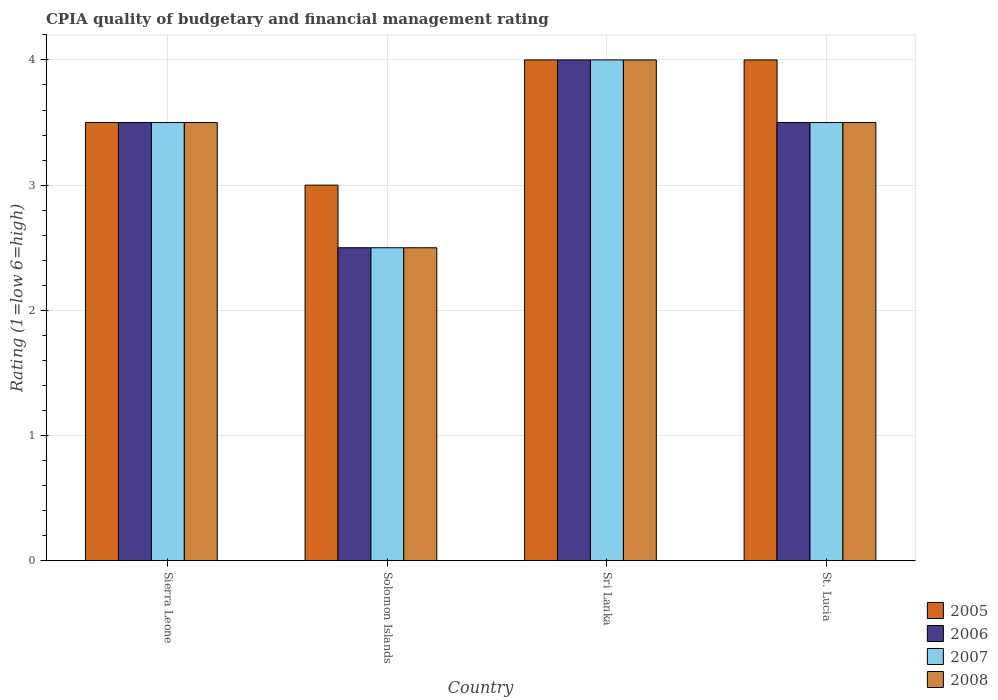How many bars are there on the 3rd tick from the left?
Your answer should be very brief. 4. How many bars are there on the 2nd tick from the right?
Offer a very short reply. 4. What is the label of the 2nd group of bars from the left?
Make the answer very short. Solomon Islands. In how many cases, is the number of bars for a given country not equal to the number of legend labels?
Your response must be concise. 0. What is the CPIA rating in 2007 in Sri Lanka?
Provide a succinct answer. 4. Across all countries, what is the maximum CPIA rating in 2005?
Keep it short and to the point. 4. Across all countries, what is the minimum CPIA rating in 2006?
Keep it short and to the point. 2.5. In which country was the CPIA rating in 2006 maximum?
Keep it short and to the point. Sri Lanka. In which country was the CPIA rating in 2006 minimum?
Your answer should be compact. Solomon Islands. What is the difference between the CPIA rating in 2005 in Sri Lanka and the CPIA rating in 2008 in Solomon Islands?
Offer a terse response. 1.5. What is the average CPIA rating in 2006 per country?
Offer a terse response. 3.38. In how many countries, is the CPIA rating in 2008 greater than 3.4?
Your answer should be compact. 3. What is the ratio of the CPIA rating in 2008 in Sierra Leone to that in St. Lucia?
Your answer should be compact. 1. What is the difference between the highest and the second highest CPIA rating in 2007?
Provide a succinct answer. -0.5. What is the difference between the highest and the lowest CPIA rating in 2006?
Provide a short and direct response. 1.5. What does the 4th bar from the left in Sierra Leone represents?
Make the answer very short. 2008. What does the 1st bar from the right in Solomon Islands represents?
Offer a very short reply. 2008. How many bars are there?
Offer a very short reply. 16. Does the graph contain any zero values?
Ensure brevity in your answer.  No. Where does the legend appear in the graph?
Offer a terse response. Bottom right. How many legend labels are there?
Keep it short and to the point. 4. How are the legend labels stacked?
Keep it short and to the point. Vertical. What is the title of the graph?
Provide a short and direct response. CPIA quality of budgetary and financial management rating. What is the label or title of the X-axis?
Keep it short and to the point. Country. What is the Rating (1=low 6=high) of 2006 in Sierra Leone?
Make the answer very short. 3.5. What is the Rating (1=low 6=high) of 2008 in Solomon Islands?
Offer a terse response. 2.5. What is the Rating (1=low 6=high) of 2006 in Sri Lanka?
Keep it short and to the point. 4. What is the Rating (1=low 6=high) in 2007 in Sri Lanka?
Offer a terse response. 4. What is the Rating (1=low 6=high) in 2005 in St. Lucia?
Make the answer very short. 4. Across all countries, what is the maximum Rating (1=low 6=high) in 2005?
Your answer should be very brief. 4. Across all countries, what is the maximum Rating (1=low 6=high) of 2006?
Ensure brevity in your answer.  4. Across all countries, what is the maximum Rating (1=low 6=high) of 2008?
Your answer should be very brief. 4. What is the total Rating (1=low 6=high) in 2005 in the graph?
Offer a very short reply. 14.5. What is the total Rating (1=low 6=high) of 2006 in the graph?
Your answer should be compact. 13.5. What is the total Rating (1=low 6=high) in 2007 in the graph?
Provide a short and direct response. 13.5. What is the difference between the Rating (1=low 6=high) of 2006 in Sierra Leone and that in Solomon Islands?
Provide a succinct answer. 1. What is the difference between the Rating (1=low 6=high) in 2008 in Sierra Leone and that in Solomon Islands?
Your response must be concise. 1. What is the difference between the Rating (1=low 6=high) of 2007 in Sierra Leone and that in Sri Lanka?
Provide a short and direct response. -0.5. What is the difference between the Rating (1=low 6=high) in 2008 in Sierra Leone and that in Sri Lanka?
Your answer should be compact. -0.5. What is the difference between the Rating (1=low 6=high) in 2005 in Sierra Leone and that in St. Lucia?
Ensure brevity in your answer.  -0.5. What is the difference between the Rating (1=low 6=high) of 2007 in Sierra Leone and that in St. Lucia?
Make the answer very short. 0. What is the difference between the Rating (1=low 6=high) of 2008 in Sierra Leone and that in St. Lucia?
Your answer should be compact. 0. What is the difference between the Rating (1=low 6=high) of 2007 in Solomon Islands and that in Sri Lanka?
Provide a succinct answer. -1.5. What is the difference between the Rating (1=low 6=high) of 2008 in Solomon Islands and that in Sri Lanka?
Offer a terse response. -1.5. What is the difference between the Rating (1=low 6=high) in 2005 in Solomon Islands and that in St. Lucia?
Offer a terse response. -1. What is the difference between the Rating (1=low 6=high) of 2006 in Solomon Islands and that in St. Lucia?
Ensure brevity in your answer.  -1. What is the difference between the Rating (1=low 6=high) in 2007 in Solomon Islands and that in St. Lucia?
Your response must be concise. -1. What is the difference between the Rating (1=low 6=high) in 2008 in Solomon Islands and that in St. Lucia?
Offer a terse response. -1. What is the difference between the Rating (1=low 6=high) in 2005 in Sri Lanka and that in St. Lucia?
Offer a terse response. 0. What is the difference between the Rating (1=low 6=high) of 2006 in Sri Lanka and that in St. Lucia?
Offer a very short reply. 0.5. What is the difference between the Rating (1=low 6=high) in 2008 in Sri Lanka and that in St. Lucia?
Your answer should be compact. 0.5. What is the difference between the Rating (1=low 6=high) in 2005 in Sierra Leone and the Rating (1=low 6=high) in 2007 in Solomon Islands?
Ensure brevity in your answer.  1. What is the difference between the Rating (1=low 6=high) of 2005 in Sierra Leone and the Rating (1=low 6=high) of 2008 in Solomon Islands?
Keep it short and to the point. 1. What is the difference between the Rating (1=low 6=high) of 2006 in Sierra Leone and the Rating (1=low 6=high) of 2008 in Solomon Islands?
Your answer should be very brief. 1. What is the difference between the Rating (1=low 6=high) of 2005 in Sierra Leone and the Rating (1=low 6=high) of 2006 in Sri Lanka?
Offer a very short reply. -0.5. What is the difference between the Rating (1=low 6=high) in 2005 in Sierra Leone and the Rating (1=low 6=high) in 2007 in Sri Lanka?
Offer a very short reply. -0.5. What is the difference between the Rating (1=low 6=high) of 2005 in Sierra Leone and the Rating (1=low 6=high) of 2008 in Sri Lanka?
Provide a succinct answer. -0.5. What is the difference between the Rating (1=low 6=high) of 2006 in Sierra Leone and the Rating (1=low 6=high) of 2007 in Sri Lanka?
Offer a very short reply. -0.5. What is the difference between the Rating (1=low 6=high) in 2006 in Sierra Leone and the Rating (1=low 6=high) in 2008 in Sri Lanka?
Make the answer very short. -0.5. What is the difference between the Rating (1=low 6=high) of 2005 in Sierra Leone and the Rating (1=low 6=high) of 2006 in St. Lucia?
Your answer should be compact. 0. What is the difference between the Rating (1=low 6=high) in 2006 in Sierra Leone and the Rating (1=low 6=high) in 2008 in St. Lucia?
Make the answer very short. 0. What is the difference between the Rating (1=low 6=high) in 2005 in Solomon Islands and the Rating (1=low 6=high) in 2007 in Sri Lanka?
Your response must be concise. -1. What is the difference between the Rating (1=low 6=high) in 2006 in Solomon Islands and the Rating (1=low 6=high) in 2007 in Sri Lanka?
Your answer should be very brief. -1.5. What is the difference between the Rating (1=low 6=high) in 2006 in Solomon Islands and the Rating (1=low 6=high) in 2008 in Sri Lanka?
Ensure brevity in your answer.  -1.5. What is the difference between the Rating (1=low 6=high) in 2006 in Solomon Islands and the Rating (1=low 6=high) in 2007 in St. Lucia?
Ensure brevity in your answer.  -1. What is the difference between the Rating (1=low 6=high) in 2006 in Solomon Islands and the Rating (1=low 6=high) in 2008 in St. Lucia?
Your answer should be very brief. -1. What is the difference between the Rating (1=low 6=high) in 2005 in Sri Lanka and the Rating (1=low 6=high) in 2007 in St. Lucia?
Provide a short and direct response. 0.5. What is the difference between the Rating (1=low 6=high) in 2005 in Sri Lanka and the Rating (1=low 6=high) in 2008 in St. Lucia?
Offer a very short reply. 0.5. What is the difference between the Rating (1=low 6=high) of 2006 in Sri Lanka and the Rating (1=low 6=high) of 2007 in St. Lucia?
Give a very brief answer. 0.5. What is the difference between the Rating (1=low 6=high) in 2006 in Sri Lanka and the Rating (1=low 6=high) in 2008 in St. Lucia?
Provide a succinct answer. 0.5. What is the difference between the Rating (1=low 6=high) of 2007 in Sri Lanka and the Rating (1=low 6=high) of 2008 in St. Lucia?
Provide a succinct answer. 0.5. What is the average Rating (1=low 6=high) in 2005 per country?
Offer a terse response. 3.62. What is the average Rating (1=low 6=high) of 2006 per country?
Provide a short and direct response. 3.38. What is the average Rating (1=low 6=high) of 2007 per country?
Make the answer very short. 3.38. What is the average Rating (1=low 6=high) in 2008 per country?
Offer a terse response. 3.38. What is the difference between the Rating (1=low 6=high) in 2005 and Rating (1=low 6=high) in 2007 in Sierra Leone?
Provide a short and direct response. 0. What is the difference between the Rating (1=low 6=high) in 2006 and Rating (1=low 6=high) in 2007 in Sierra Leone?
Offer a terse response. 0. What is the difference between the Rating (1=low 6=high) of 2007 and Rating (1=low 6=high) of 2008 in Sierra Leone?
Make the answer very short. 0. What is the difference between the Rating (1=low 6=high) of 2005 and Rating (1=low 6=high) of 2007 in Solomon Islands?
Offer a very short reply. 0.5. What is the difference between the Rating (1=low 6=high) of 2007 and Rating (1=low 6=high) of 2008 in Solomon Islands?
Offer a very short reply. 0. What is the difference between the Rating (1=low 6=high) of 2005 and Rating (1=low 6=high) of 2006 in Sri Lanka?
Provide a short and direct response. 0. What is the difference between the Rating (1=low 6=high) in 2005 and Rating (1=low 6=high) in 2008 in Sri Lanka?
Offer a terse response. 0. What is the difference between the Rating (1=low 6=high) of 2006 and Rating (1=low 6=high) of 2008 in Sri Lanka?
Make the answer very short. 0. What is the difference between the Rating (1=low 6=high) in 2005 and Rating (1=low 6=high) in 2006 in St. Lucia?
Make the answer very short. 0.5. What is the difference between the Rating (1=low 6=high) of 2005 and Rating (1=low 6=high) of 2007 in St. Lucia?
Provide a succinct answer. 0.5. What is the difference between the Rating (1=low 6=high) in 2006 and Rating (1=low 6=high) in 2007 in St. Lucia?
Make the answer very short. 0. What is the difference between the Rating (1=low 6=high) in 2006 and Rating (1=low 6=high) in 2008 in St. Lucia?
Keep it short and to the point. 0. What is the ratio of the Rating (1=low 6=high) in 2006 in Sierra Leone to that in Solomon Islands?
Give a very brief answer. 1.4. What is the ratio of the Rating (1=low 6=high) of 2007 in Sierra Leone to that in Solomon Islands?
Your answer should be very brief. 1.4. What is the ratio of the Rating (1=low 6=high) of 2005 in Sierra Leone to that in Sri Lanka?
Offer a very short reply. 0.88. What is the ratio of the Rating (1=low 6=high) of 2006 in Sierra Leone to that in Sri Lanka?
Give a very brief answer. 0.88. What is the ratio of the Rating (1=low 6=high) of 2007 in Sierra Leone to that in Sri Lanka?
Make the answer very short. 0.88. What is the ratio of the Rating (1=low 6=high) in 2005 in Sierra Leone to that in St. Lucia?
Offer a terse response. 0.88. What is the ratio of the Rating (1=low 6=high) of 2008 in Sierra Leone to that in St. Lucia?
Ensure brevity in your answer.  1. What is the ratio of the Rating (1=low 6=high) in 2005 in Solomon Islands to that in Sri Lanka?
Offer a very short reply. 0.75. What is the ratio of the Rating (1=low 6=high) of 2007 in Solomon Islands to that in Sri Lanka?
Your response must be concise. 0.62. What is the ratio of the Rating (1=low 6=high) in 2005 in Solomon Islands to that in St. Lucia?
Offer a terse response. 0.75. What is the ratio of the Rating (1=low 6=high) of 2005 in Sri Lanka to that in St. Lucia?
Your response must be concise. 1. What is the ratio of the Rating (1=low 6=high) of 2006 in Sri Lanka to that in St. Lucia?
Offer a very short reply. 1.14. What is the ratio of the Rating (1=low 6=high) in 2008 in Sri Lanka to that in St. Lucia?
Ensure brevity in your answer.  1.14. What is the difference between the highest and the second highest Rating (1=low 6=high) in 2005?
Keep it short and to the point. 0. What is the difference between the highest and the second highest Rating (1=low 6=high) in 2006?
Give a very brief answer. 0.5. What is the difference between the highest and the second highest Rating (1=low 6=high) in 2008?
Give a very brief answer. 0.5. What is the difference between the highest and the lowest Rating (1=low 6=high) of 2007?
Provide a succinct answer. 1.5. What is the difference between the highest and the lowest Rating (1=low 6=high) in 2008?
Your answer should be compact. 1.5. 